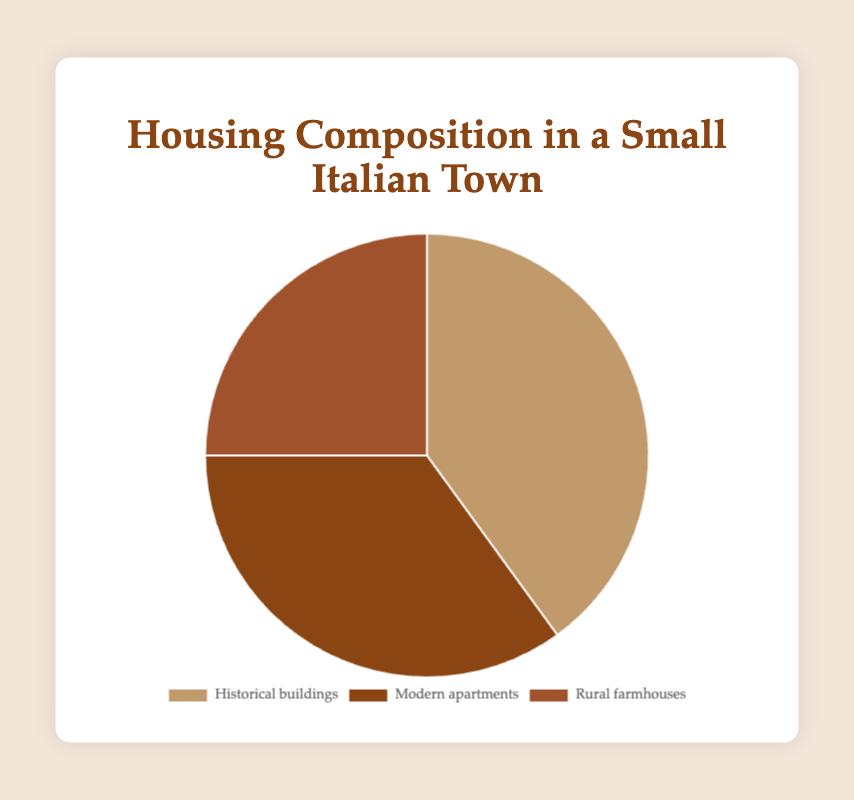What percentage of housing in the town is made up of Historical buildings? Historical buildings account for 40% of the housing composition in the town as shown in the pie chart.
Answer: 40% How much larger is the percentage of Historical buildings compared to Rural farmhouses? The difference is found by subtracting the percentage of Rural farmhouses from Historical buildings: 40% - 25% = 15%.
Answer: 15% Which type of housing has the smallest representation? The Rural farmhouses have the smallest representation in the pie chart with 25%.
Answer: Rural farmhouses What is the combined percentage of Historical buildings and Modern apartments? The combined percentage is the sum of Historical buildings and Modern apartments: 40% + 35% = 75%.
Answer: 75% Is the percentage of Modern apartments greater than or less than the percentage of Historical buildings? Compare the two percentages: 35% for Modern apartments and 40% for Historical buildings.
Answer: Less than How does the percentage of Rural farmhouses compare to Modern apartments in terms of visual representation? Rural farmhouses have 25% and Modern apartments have 35%. Observing the pie chart colors can help confirm this difference visually.
Answer: Less than What percentage of housing is not represented by Modern apartments? Subtract the percentage of Modern apartments from 100%: 100% - 35% = 65%.
Answer: 65% Identify the type of housing that uses the darkest shade in the pie chart. Observing the color shading in the pie chart, the darkest shade represents Modern apartments.
Answer: Modern apartments Estimate the average percentage of all three types of housing. Sum the percentages of the three types and divide by 3: (40% + 35% + 25%) / 3 = 33.33%.
Answer: 33.33% 